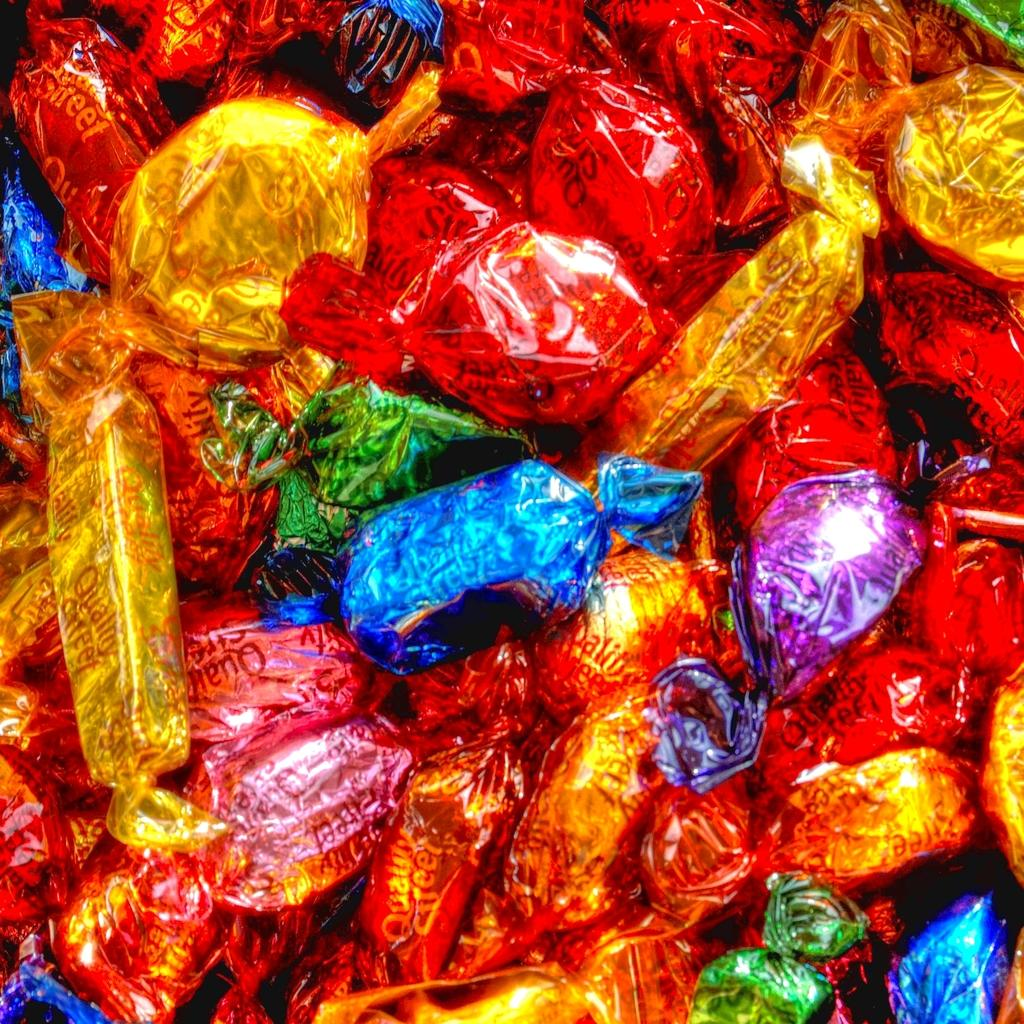What type of food is present in the image? There are chocolates in the image. What colors are the chocolate covers? The chocolates have red, golden, blue, violet, pink, and green color covers. How many brothers are depicted in the image? There are no people, including brothers, present in the image; it only features chocolates with different colored covers. 